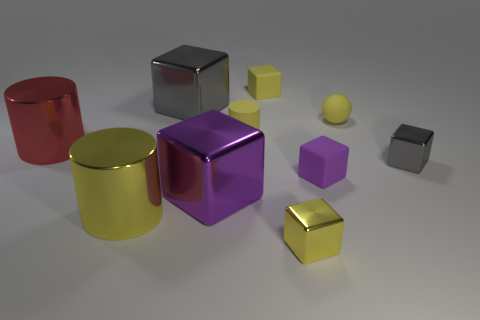There is a tiny yellow matte cylinder; are there any shiny cubes behind it?
Your response must be concise. Yes. How big is the gray shiny object that is behind the gray thing to the right of the big gray object?
Your answer should be compact. Large. Is the number of tiny purple blocks to the left of the matte cylinder the same as the number of small yellow spheres that are on the right side of the large yellow thing?
Make the answer very short. No. Are there any big yellow metallic cylinders on the right side of the yellow matte thing that is on the left side of the tiny yellow rubber block?
Provide a succinct answer. No. How many large red metallic cylinders are in front of the purple block that is on the right side of the yellow cube behind the large yellow metal cylinder?
Offer a terse response. 0. Is the number of big cyan cylinders less than the number of metallic objects?
Provide a succinct answer. Yes. Do the gray metallic thing behind the tiny yellow sphere and the purple shiny thing right of the large yellow metal thing have the same shape?
Offer a terse response. Yes. The small cylinder has what color?
Make the answer very short. Yellow. How many matte objects are either tiny yellow spheres or tiny gray cubes?
Provide a short and direct response. 1. What color is the other big shiny thing that is the same shape as the big purple thing?
Provide a succinct answer. Gray. 